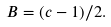<formula> <loc_0><loc_0><loc_500><loc_500>B = ( c - 1 ) / 2 .</formula> 